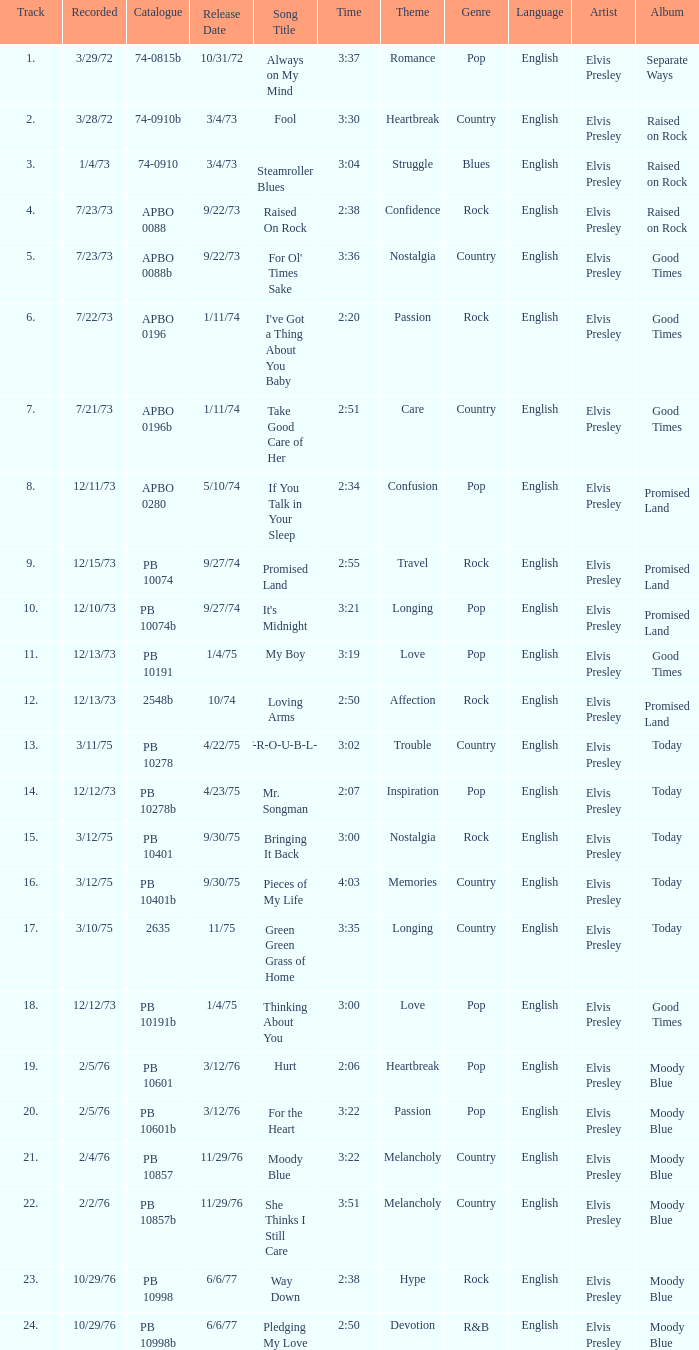Name the catalogue that has tracks less than 13 and the release date of 10/31/72 74-0815b. 